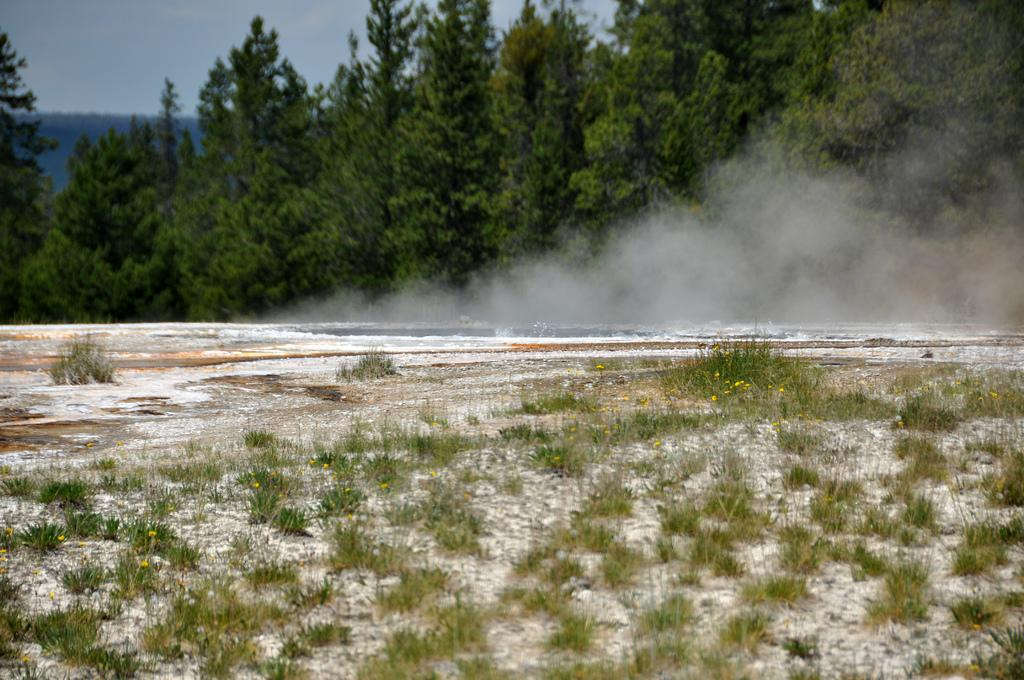What type of surface is visible in the image? There is a surface with grass in the image. What can be seen coming from the surface? Smoke is visible from the surface. What is visible in the background of the image? There are trees and the sky in the background of the image. What type of animal is holding the pail in the image? There is no animal or pail present in the image. 